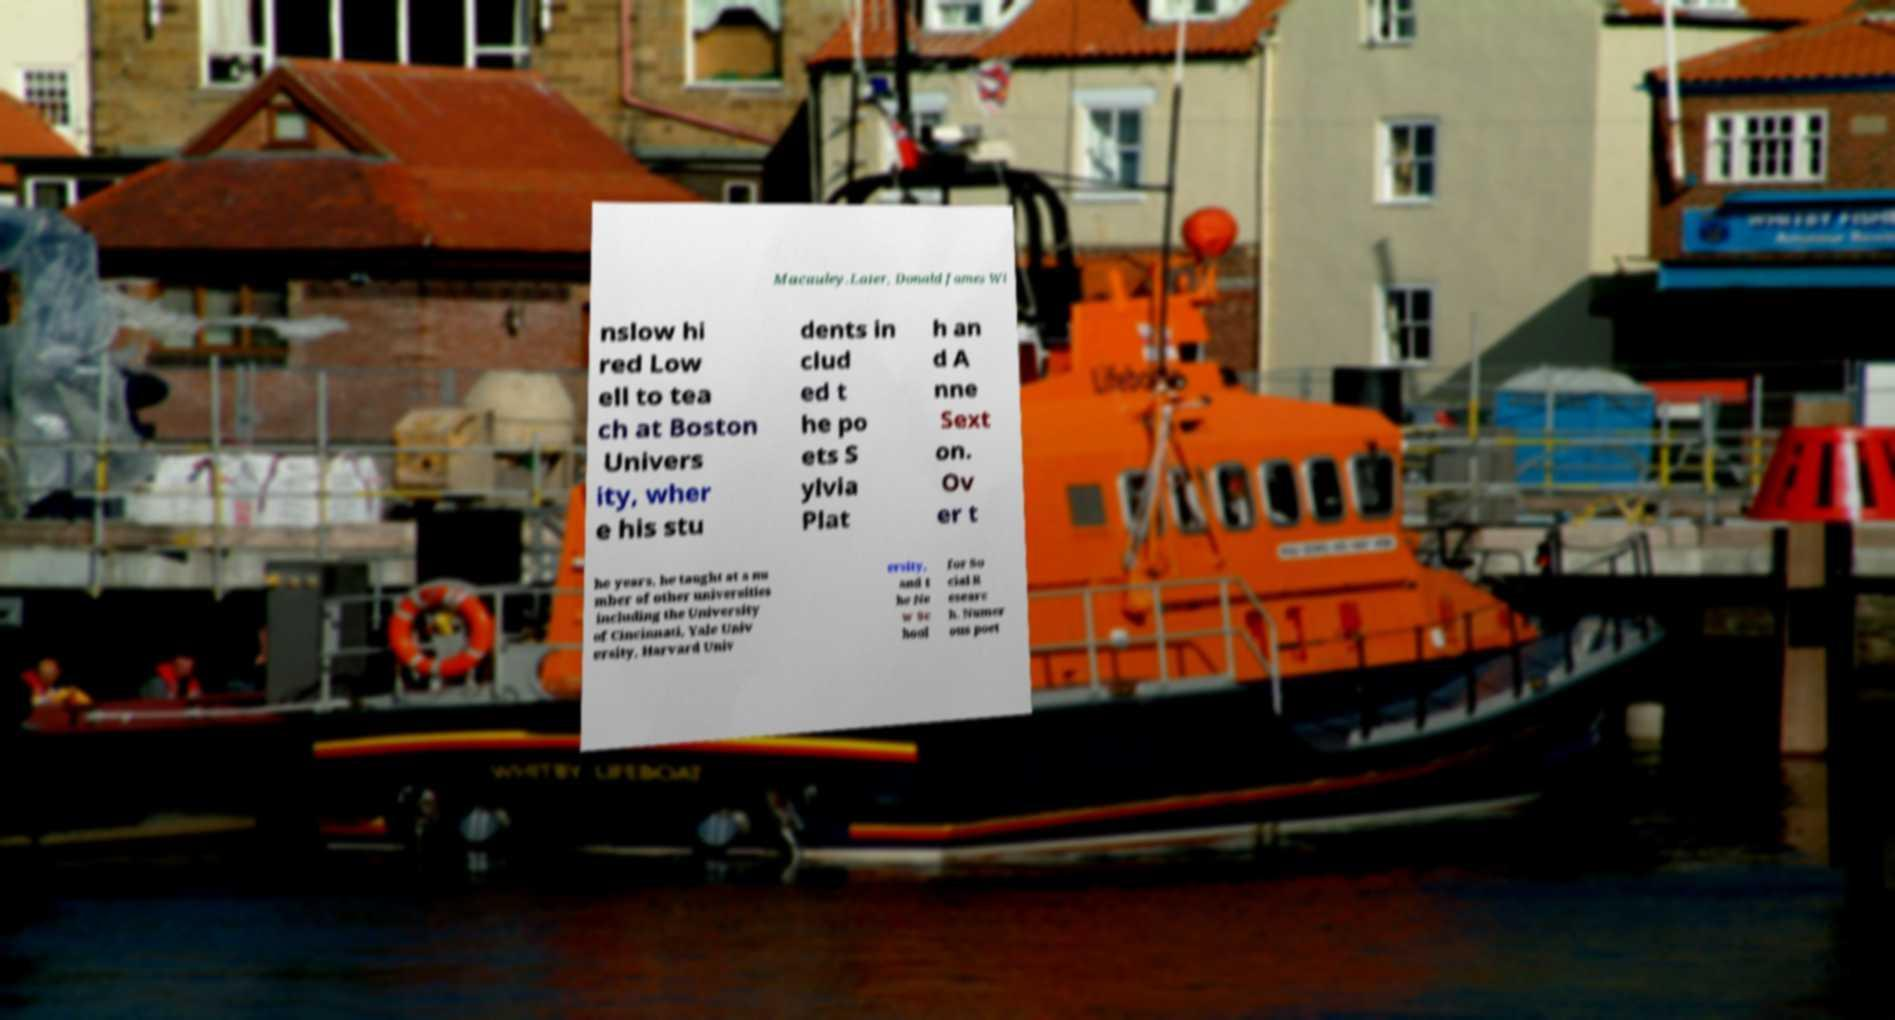Can you accurately transcribe the text from the provided image for me? Macauley.Later, Donald James Wi nslow hi red Low ell to tea ch at Boston Univers ity, wher e his stu dents in clud ed t he po ets S ylvia Plat h an d A nne Sext on. Ov er t he years, he taught at a nu mber of other universities including the University of Cincinnati, Yale Univ ersity, Harvard Univ ersity, and t he Ne w Sc hool for So cial R esearc h. Numer ous poet 